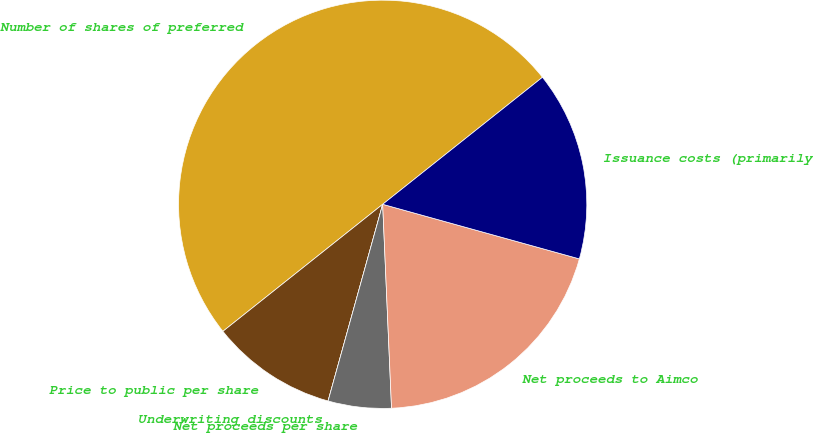Convert chart to OTSL. <chart><loc_0><loc_0><loc_500><loc_500><pie_chart><fcel>Number of shares of preferred<fcel>Price to public per share<fcel>Underwriting discounts<fcel>Net proceeds per share<fcel>Net proceeds to Aimco<fcel>Issuance costs (primarily<nl><fcel>50.0%<fcel>10.0%<fcel>0.0%<fcel>5.0%<fcel>20.0%<fcel>15.0%<nl></chart> 